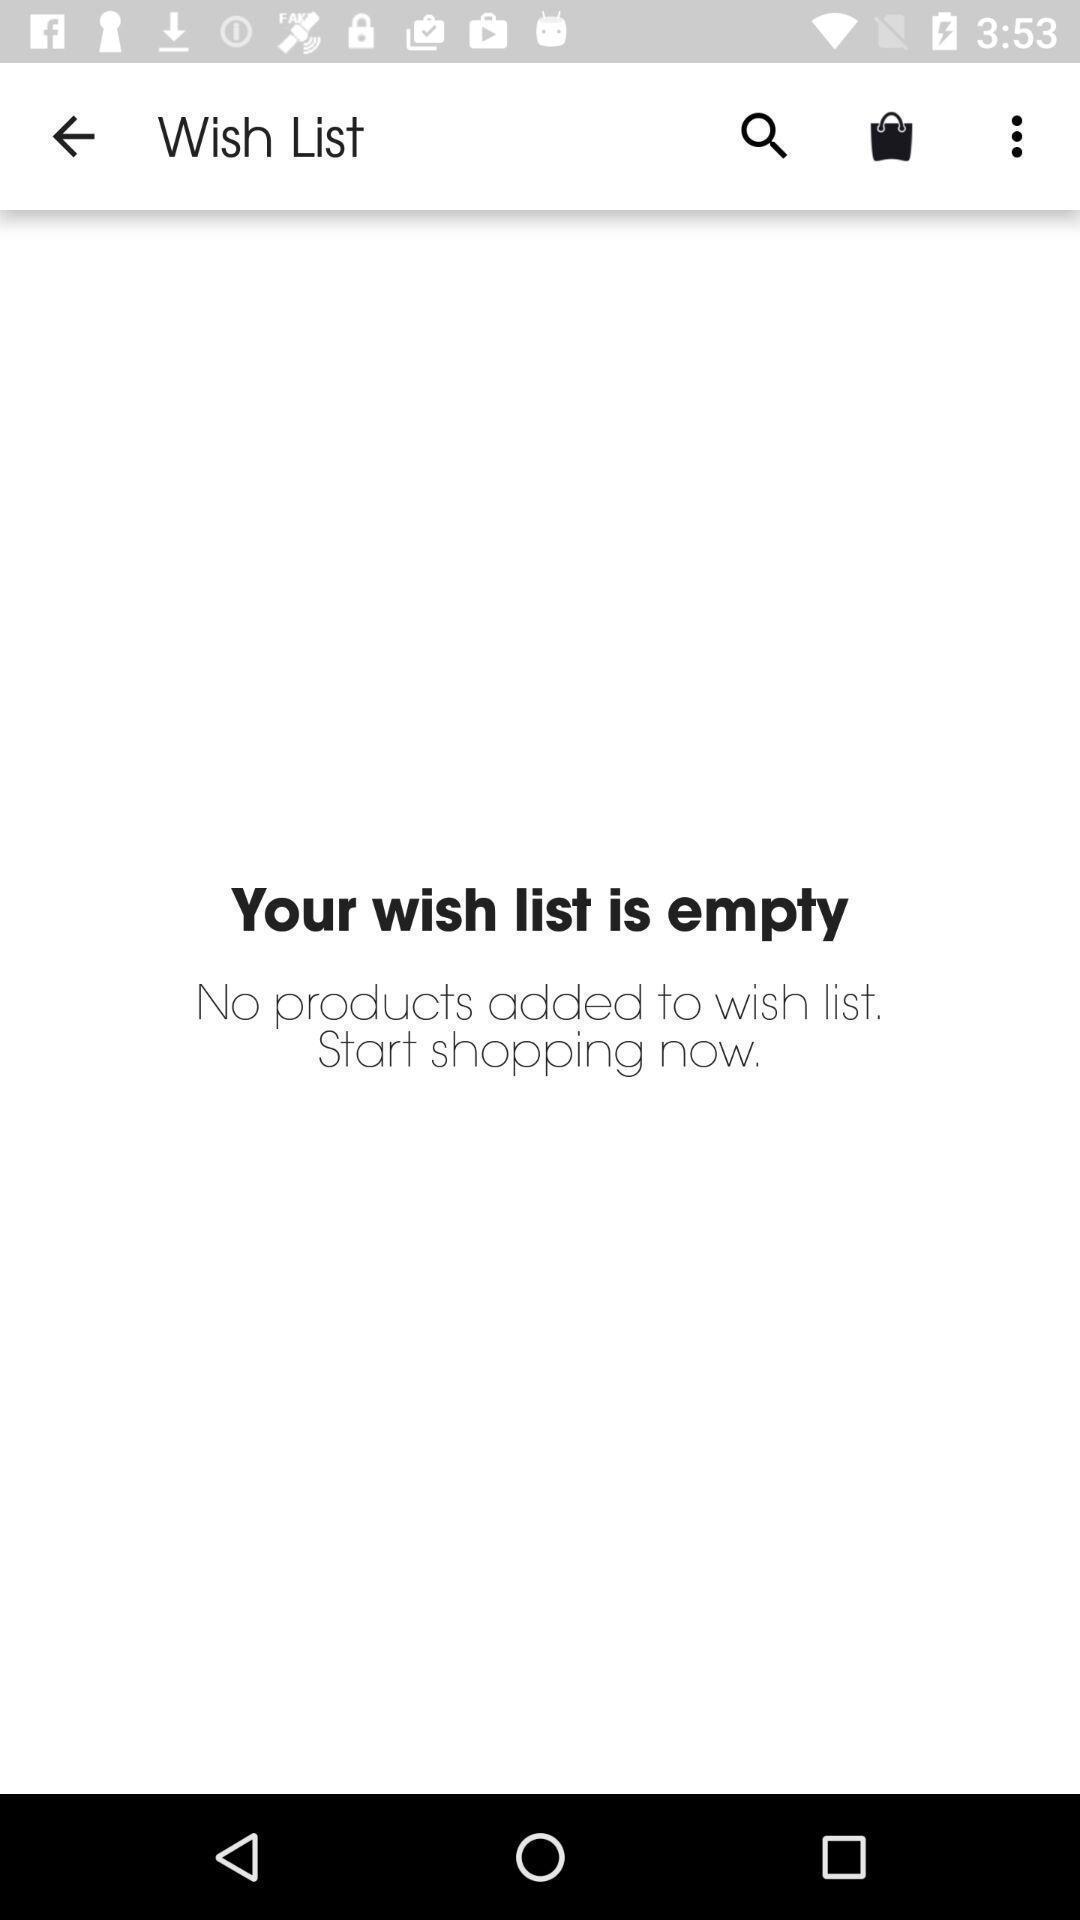Summarize the main components in this picture. Wish list page of a shopping app. 